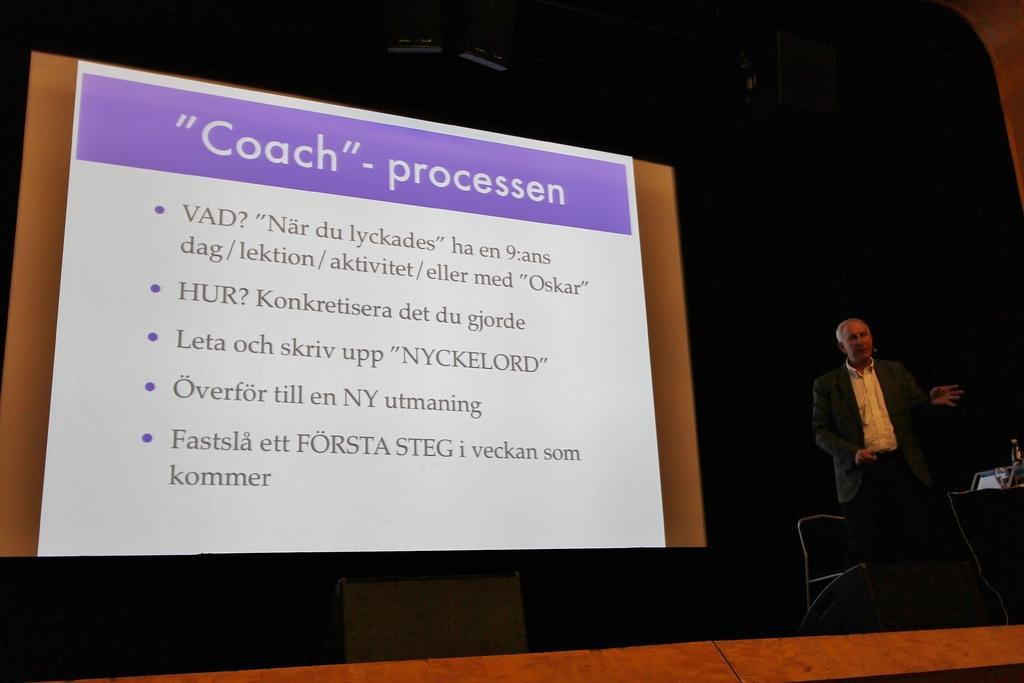Can you describe this image briefly? In this picture we can see a man, he is standing, beside to him we can see a chair and a projector screen. 